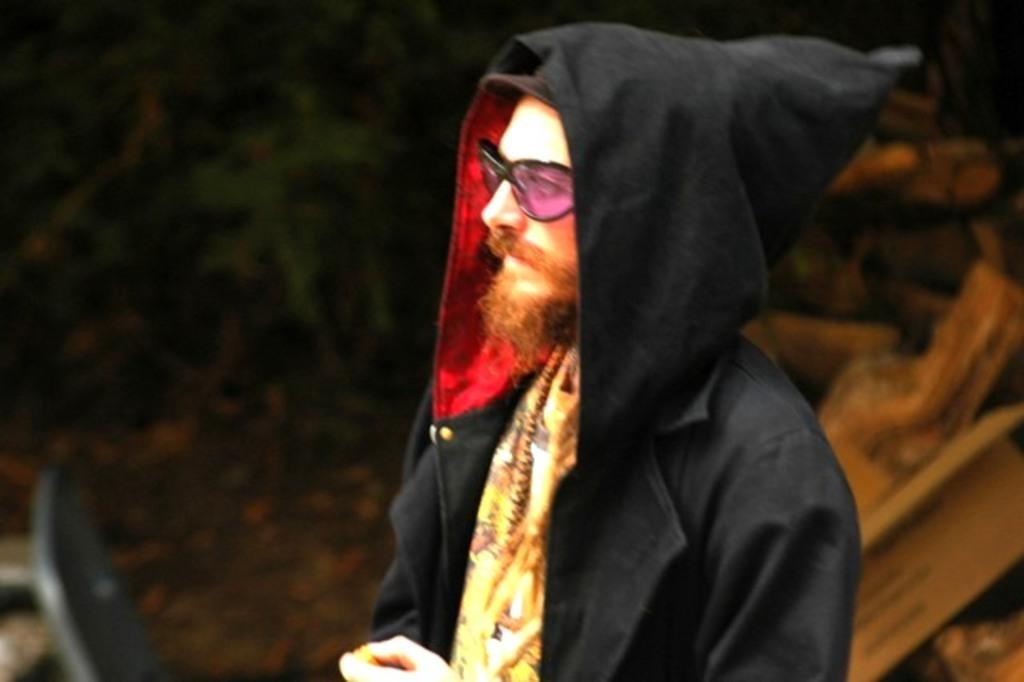What is the main subject of the image? There is a person standing in the image. Can you describe the background of the image? The background of the image is blurry. What type of act is the person performing in the image? There is no specific act being performed by the person in the image. What thoughts might the person be having in the image? We cannot determine the person's thoughts from the image alone. Can you see a frog in the image? There is no frog present in the image. 